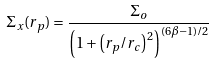Convert formula to latex. <formula><loc_0><loc_0><loc_500><loc_500>\Sigma _ { x } ( r _ { p } ) = \frac { \Sigma _ { o } } { { \left ( 1 + { \left ( r _ { p } / r _ { c } \right ) } ^ { 2 } \right ) } ^ { ( 6 \beta - 1 ) / 2 } }</formula> 